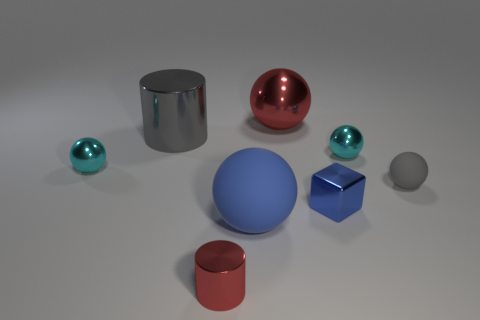There is a large object that is the same color as the small rubber sphere; what is it made of?
Offer a very short reply. Metal. There is a metallic block that is the same color as the big rubber thing; what size is it?
Offer a terse response. Small. Do the large cylinder and the small matte object have the same color?
Keep it short and to the point. Yes. Does the big ball behind the big gray thing have the same color as the tiny cylinder?
Make the answer very short. Yes. Is there a big metallic sphere of the same color as the small cylinder?
Your response must be concise. Yes. Are there any other things that are the same color as the large rubber thing?
Provide a succinct answer. Yes. There is a shiny object that is the same color as the large metallic sphere; what is its shape?
Offer a terse response. Cylinder. The red metal object that is the same size as the blue shiny object is what shape?
Offer a terse response. Cylinder. How many things are either large gray metallic cylinders or large purple metal objects?
Offer a terse response. 1. Are there any large red metallic balls?
Offer a very short reply. Yes. 